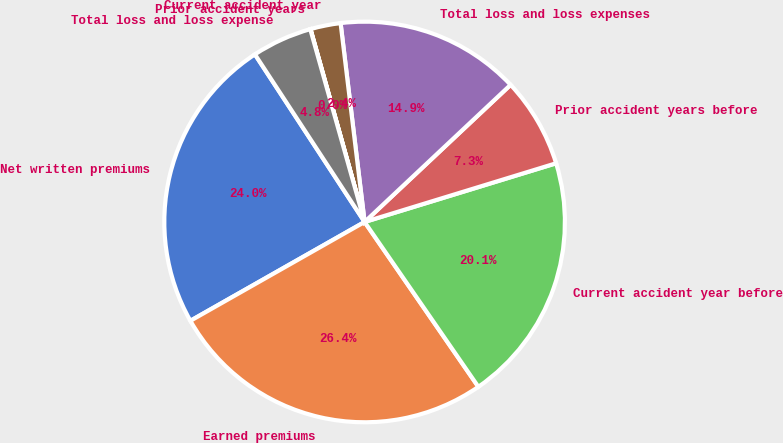Convert chart. <chart><loc_0><loc_0><loc_500><loc_500><pie_chart><fcel>Net written premiums<fcel>Earned premiums<fcel>Current accident year before<fcel>Prior accident years before<fcel>Total loss and loss expenses<fcel>Current accident year<fcel>Prior accident years<fcel>Total loss and loss expense<nl><fcel>23.99%<fcel>26.4%<fcel>20.12%<fcel>7.27%<fcel>14.91%<fcel>2.44%<fcel>0.02%<fcel>4.85%<nl></chart> 